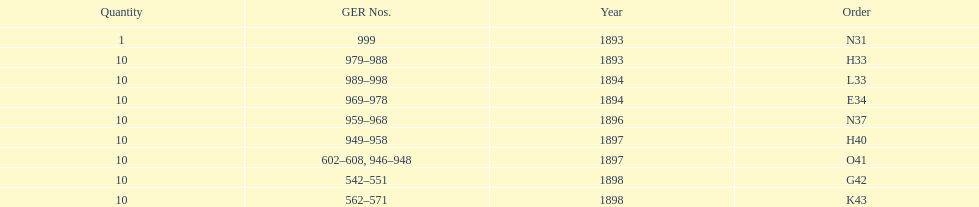Which order was the next order after l33? E34. 